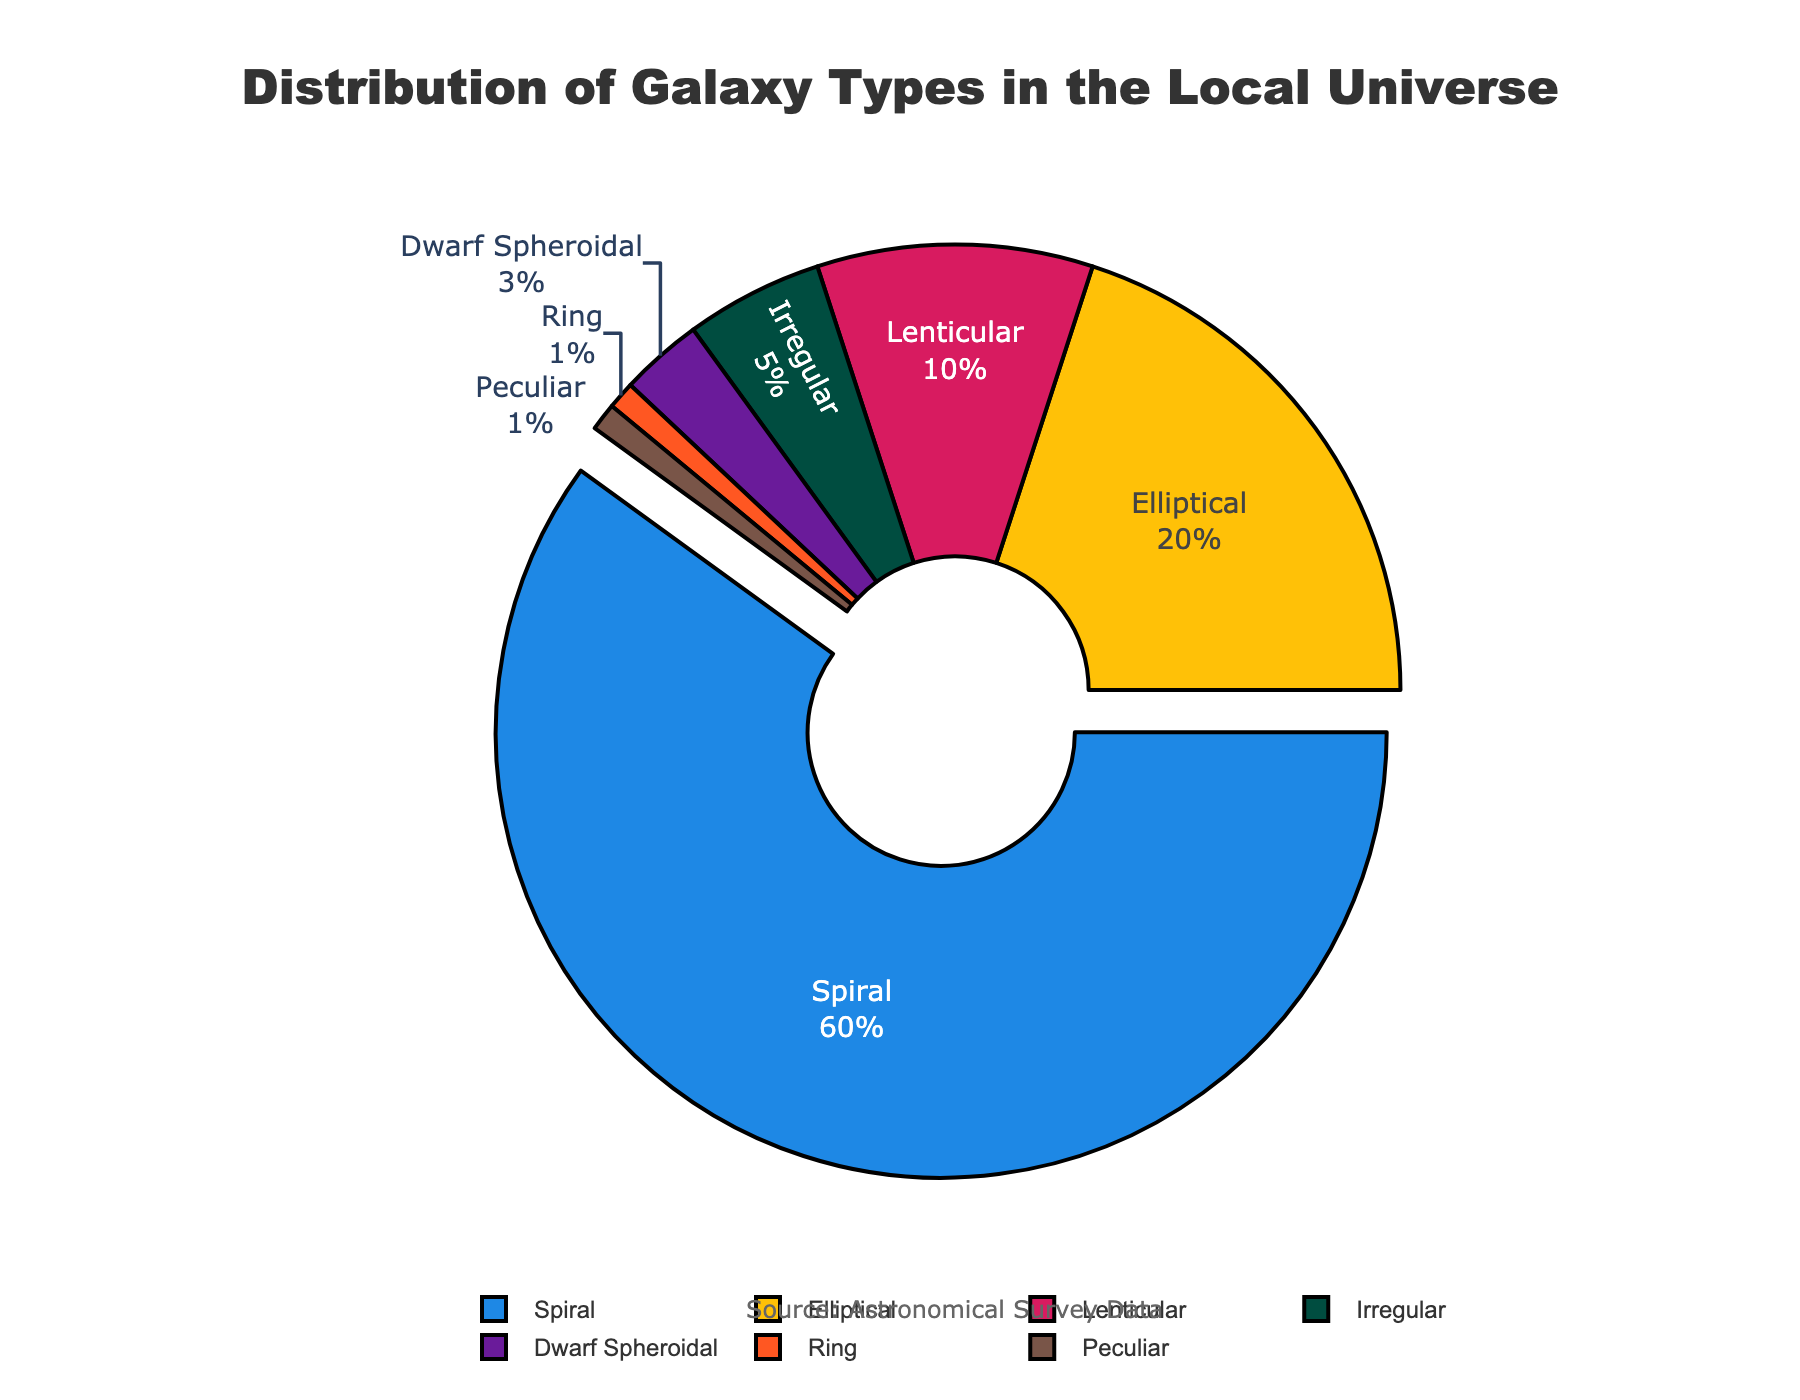What is the most common type of galaxy in the local universe? The pie chart shows the distribution of galaxy types, and the largest segment indicates the most common type. The "Spiral" galaxy type comprises 60% of the local universe, making it the most common.
Answer: Spiral Which galaxy type has the smallest representation in the local universe? The smallest segment in the pie chart represents the least common type of galaxy. Both "Ring" and "Peculiar" galaxies each make up 1% of the local universe.
Answer: Ring and Peculiar What is the combined percentage of Elliptical and Lenticular galaxies? The pie chart shows 20% for Elliptical galaxies and 10% for Lenticular galaxies. Combining these percentages yields 20% + 10% = 30%.
Answer: 30% Are there more Elliptical galaxies or Irregular galaxies in the local universe? By comparing the sizes of the segments, Elliptical galaxies (20%) have a larger representation than Irregular galaxies (5%) in the pie chart.
Answer: Elliptical What is the difference in percentage between Spiral and Dwarf Spheroidal galaxies? Spiral galaxies make up 60% and Dwarf Spheroidal galaxies make up 3%. The difference is 60% - 3% = 57%.
Answer: 57% Which types of galaxies combined make up less than 10% of the local universe? Analyzing the smaller segments, "Irregular" (5%), "Dwarf Spheroidal" (3%), "Ring" (1%), and "Peculiar" (1%) all individually add up to less than 10%.
Answer: Irregular, Dwarf Spheroidal, Ring, Peculiar What is the visual indicator for the most occurring galaxy type in the pie chart? The largest segment, highlighted by being pulled out slightly from the pie chart, indicates the most common galaxy type. In this chart, it’s the Spiral galaxy.
Answer: The pulled out segment How could the visual rotation (starting angle) of the pie chart affect the perception of the data? Changing the starting angle changes which segment is positioned at the top of the chart, possibly altering initial perceptions of which segment is most common.
Answer: It could influence initial perceptions of the most common galaxy type What's the relationship between the percentages of Lenticular and Irregular galaxies? The Lenticular galaxies account for 10%, which is double the percentage of Irregular galaxies at 5%.
Answer: Lenticular is double Irregular Is the sum of the percentages of Peculiar, Ring, and Dwarf Spheroidal galaxies greater or less than the percentage of Elliptical galaxies? Adding the percentages: Peculiar (1%) + Ring (1%) + Dwarf Spheroidal (3%) equals 5%. Comparing this sum, 5% is less than the 20% of Elliptical galaxies.
Answer: less 